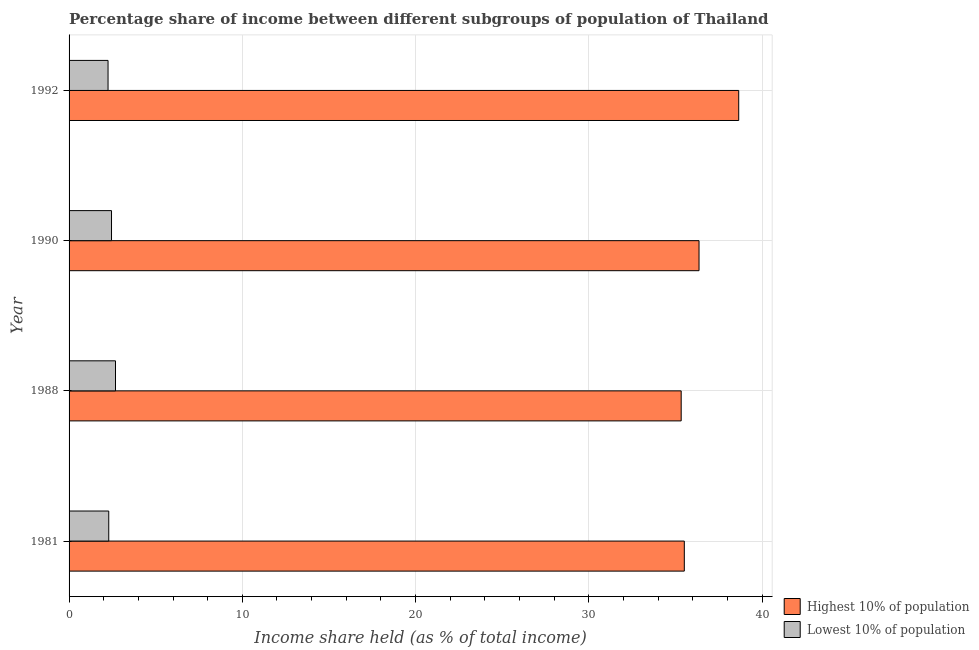Are the number of bars per tick equal to the number of legend labels?
Give a very brief answer. Yes. Are the number of bars on each tick of the Y-axis equal?
Offer a terse response. Yes. How many bars are there on the 2nd tick from the top?
Keep it short and to the point. 2. What is the label of the 2nd group of bars from the top?
Ensure brevity in your answer.  1990. In how many cases, is the number of bars for a given year not equal to the number of legend labels?
Ensure brevity in your answer.  0. What is the income share held by lowest 10% of the population in 1981?
Provide a short and direct response. 2.29. Across all years, what is the maximum income share held by highest 10% of the population?
Your response must be concise. 38.65. Across all years, what is the minimum income share held by highest 10% of the population?
Your answer should be compact. 35.33. In which year was the income share held by highest 10% of the population maximum?
Your answer should be compact. 1992. In which year was the income share held by highest 10% of the population minimum?
Offer a very short reply. 1988. What is the total income share held by highest 10% of the population in the graph?
Provide a short and direct response. 145.85. What is the difference between the income share held by lowest 10% of the population in 1990 and that in 1992?
Offer a very short reply. 0.2. What is the difference between the income share held by lowest 10% of the population in 1990 and the income share held by highest 10% of the population in 1992?
Provide a succinct answer. -36.2. What is the average income share held by highest 10% of the population per year?
Provide a succinct answer. 36.46. In the year 1990, what is the difference between the income share held by lowest 10% of the population and income share held by highest 10% of the population?
Your response must be concise. -33.91. In how many years, is the income share held by highest 10% of the population greater than 28 %?
Give a very brief answer. 4. What is the ratio of the income share held by lowest 10% of the population in 1988 to that in 1992?
Offer a terse response. 1.19. Is the difference between the income share held by lowest 10% of the population in 1988 and 1992 greater than the difference between the income share held by highest 10% of the population in 1988 and 1992?
Your response must be concise. Yes. What is the difference between the highest and the second highest income share held by lowest 10% of the population?
Ensure brevity in your answer.  0.23. What is the difference between the highest and the lowest income share held by highest 10% of the population?
Your answer should be very brief. 3.32. What does the 2nd bar from the top in 1990 represents?
Your answer should be compact. Highest 10% of population. What does the 1st bar from the bottom in 1988 represents?
Your answer should be very brief. Highest 10% of population. How many bars are there?
Keep it short and to the point. 8. Are all the bars in the graph horizontal?
Offer a very short reply. Yes. Are the values on the major ticks of X-axis written in scientific E-notation?
Your answer should be very brief. No. How many legend labels are there?
Provide a succinct answer. 2. How are the legend labels stacked?
Your answer should be very brief. Vertical. What is the title of the graph?
Your response must be concise. Percentage share of income between different subgroups of population of Thailand. Does "Birth rate" appear as one of the legend labels in the graph?
Your response must be concise. No. What is the label or title of the X-axis?
Your answer should be compact. Income share held (as % of total income). What is the Income share held (as % of total income) in Highest 10% of population in 1981?
Offer a terse response. 35.51. What is the Income share held (as % of total income) in Lowest 10% of population in 1981?
Provide a succinct answer. 2.29. What is the Income share held (as % of total income) in Highest 10% of population in 1988?
Your answer should be compact. 35.33. What is the Income share held (as % of total income) of Lowest 10% of population in 1988?
Offer a very short reply. 2.68. What is the Income share held (as % of total income) of Highest 10% of population in 1990?
Provide a succinct answer. 36.36. What is the Income share held (as % of total income) of Lowest 10% of population in 1990?
Your answer should be very brief. 2.45. What is the Income share held (as % of total income) in Highest 10% of population in 1992?
Provide a succinct answer. 38.65. What is the Income share held (as % of total income) in Lowest 10% of population in 1992?
Your answer should be compact. 2.25. Across all years, what is the maximum Income share held (as % of total income) in Highest 10% of population?
Provide a succinct answer. 38.65. Across all years, what is the maximum Income share held (as % of total income) of Lowest 10% of population?
Offer a very short reply. 2.68. Across all years, what is the minimum Income share held (as % of total income) in Highest 10% of population?
Give a very brief answer. 35.33. Across all years, what is the minimum Income share held (as % of total income) in Lowest 10% of population?
Give a very brief answer. 2.25. What is the total Income share held (as % of total income) of Highest 10% of population in the graph?
Offer a very short reply. 145.85. What is the total Income share held (as % of total income) in Lowest 10% of population in the graph?
Your answer should be compact. 9.67. What is the difference between the Income share held (as % of total income) in Highest 10% of population in 1981 and that in 1988?
Keep it short and to the point. 0.18. What is the difference between the Income share held (as % of total income) in Lowest 10% of population in 1981 and that in 1988?
Provide a short and direct response. -0.39. What is the difference between the Income share held (as % of total income) in Highest 10% of population in 1981 and that in 1990?
Offer a terse response. -0.85. What is the difference between the Income share held (as % of total income) in Lowest 10% of population in 1981 and that in 1990?
Give a very brief answer. -0.16. What is the difference between the Income share held (as % of total income) of Highest 10% of population in 1981 and that in 1992?
Offer a very short reply. -3.14. What is the difference between the Income share held (as % of total income) of Highest 10% of population in 1988 and that in 1990?
Provide a succinct answer. -1.03. What is the difference between the Income share held (as % of total income) of Lowest 10% of population in 1988 and that in 1990?
Keep it short and to the point. 0.23. What is the difference between the Income share held (as % of total income) in Highest 10% of population in 1988 and that in 1992?
Make the answer very short. -3.32. What is the difference between the Income share held (as % of total income) in Lowest 10% of population in 1988 and that in 1992?
Make the answer very short. 0.43. What is the difference between the Income share held (as % of total income) of Highest 10% of population in 1990 and that in 1992?
Your answer should be very brief. -2.29. What is the difference between the Income share held (as % of total income) of Highest 10% of population in 1981 and the Income share held (as % of total income) of Lowest 10% of population in 1988?
Ensure brevity in your answer.  32.83. What is the difference between the Income share held (as % of total income) of Highest 10% of population in 1981 and the Income share held (as % of total income) of Lowest 10% of population in 1990?
Give a very brief answer. 33.06. What is the difference between the Income share held (as % of total income) of Highest 10% of population in 1981 and the Income share held (as % of total income) of Lowest 10% of population in 1992?
Ensure brevity in your answer.  33.26. What is the difference between the Income share held (as % of total income) of Highest 10% of population in 1988 and the Income share held (as % of total income) of Lowest 10% of population in 1990?
Keep it short and to the point. 32.88. What is the difference between the Income share held (as % of total income) of Highest 10% of population in 1988 and the Income share held (as % of total income) of Lowest 10% of population in 1992?
Your response must be concise. 33.08. What is the difference between the Income share held (as % of total income) of Highest 10% of population in 1990 and the Income share held (as % of total income) of Lowest 10% of population in 1992?
Keep it short and to the point. 34.11. What is the average Income share held (as % of total income) in Highest 10% of population per year?
Your response must be concise. 36.46. What is the average Income share held (as % of total income) of Lowest 10% of population per year?
Offer a terse response. 2.42. In the year 1981, what is the difference between the Income share held (as % of total income) of Highest 10% of population and Income share held (as % of total income) of Lowest 10% of population?
Make the answer very short. 33.22. In the year 1988, what is the difference between the Income share held (as % of total income) of Highest 10% of population and Income share held (as % of total income) of Lowest 10% of population?
Ensure brevity in your answer.  32.65. In the year 1990, what is the difference between the Income share held (as % of total income) of Highest 10% of population and Income share held (as % of total income) of Lowest 10% of population?
Offer a very short reply. 33.91. In the year 1992, what is the difference between the Income share held (as % of total income) in Highest 10% of population and Income share held (as % of total income) in Lowest 10% of population?
Your answer should be compact. 36.4. What is the ratio of the Income share held (as % of total income) of Highest 10% of population in 1981 to that in 1988?
Ensure brevity in your answer.  1.01. What is the ratio of the Income share held (as % of total income) of Lowest 10% of population in 1981 to that in 1988?
Your answer should be compact. 0.85. What is the ratio of the Income share held (as % of total income) in Highest 10% of population in 1981 to that in 1990?
Your response must be concise. 0.98. What is the ratio of the Income share held (as % of total income) of Lowest 10% of population in 1981 to that in 1990?
Your response must be concise. 0.93. What is the ratio of the Income share held (as % of total income) in Highest 10% of population in 1981 to that in 1992?
Provide a succinct answer. 0.92. What is the ratio of the Income share held (as % of total income) in Lowest 10% of population in 1981 to that in 1992?
Ensure brevity in your answer.  1.02. What is the ratio of the Income share held (as % of total income) of Highest 10% of population in 1988 to that in 1990?
Your answer should be very brief. 0.97. What is the ratio of the Income share held (as % of total income) of Lowest 10% of population in 1988 to that in 1990?
Offer a very short reply. 1.09. What is the ratio of the Income share held (as % of total income) of Highest 10% of population in 1988 to that in 1992?
Give a very brief answer. 0.91. What is the ratio of the Income share held (as % of total income) in Lowest 10% of population in 1988 to that in 1992?
Provide a succinct answer. 1.19. What is the ratio of the Income share held (as % of total income) of Highest 10% of population in 1990 to that in 1992?
Give a very brief answer. 0.94. What is the ratio of the Income share held (as % of total income) in Lowest 10% of population in 1990 to that in 1992?
Your answer should be very brief. 1.09. What is the difference between the highest and the second highest Income share held (as % of total income) in Highest 10% of population?
Make the answer very short. 2.29. What is the difference between the highest and the second highest Income share held (as % of total income) of Lowest 10% of population?
Provide a short and direct response. 0.23. What is the difference between the highest and the lowest Income share held (as % of total income) of Highest 10% of population?
Make the answer very short. 3.32. What is the difference between the highest and the lowest Income share held (as % of total income) of Lowest 10% of population?
Your answer should be very brief. 0.43. 